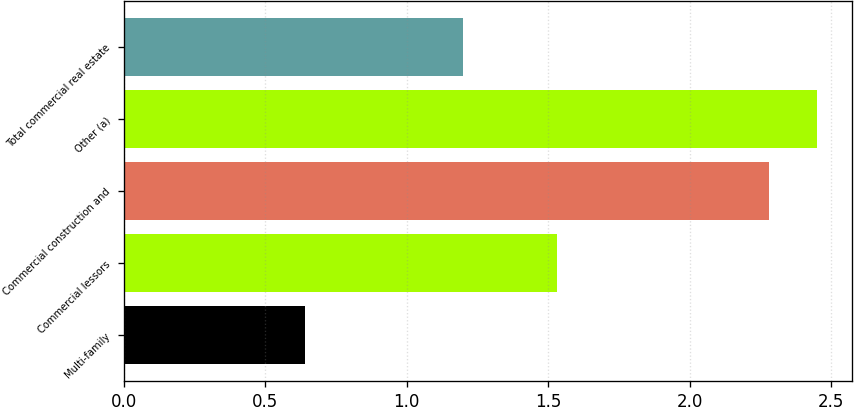Convert chart. <chart><loc_0><loc_0><loc_500><loc_500><bar_chart><fcel>Multi-family<fcel>Commercial lessors<fcel>Commercial construction and<fcel>Other (a)<fcel>Total commercial real estate<nl><fcel>0.64<fcel>1.53<fcel>2.28<fcel>2.45<fcel>1.2<nl></chart> 